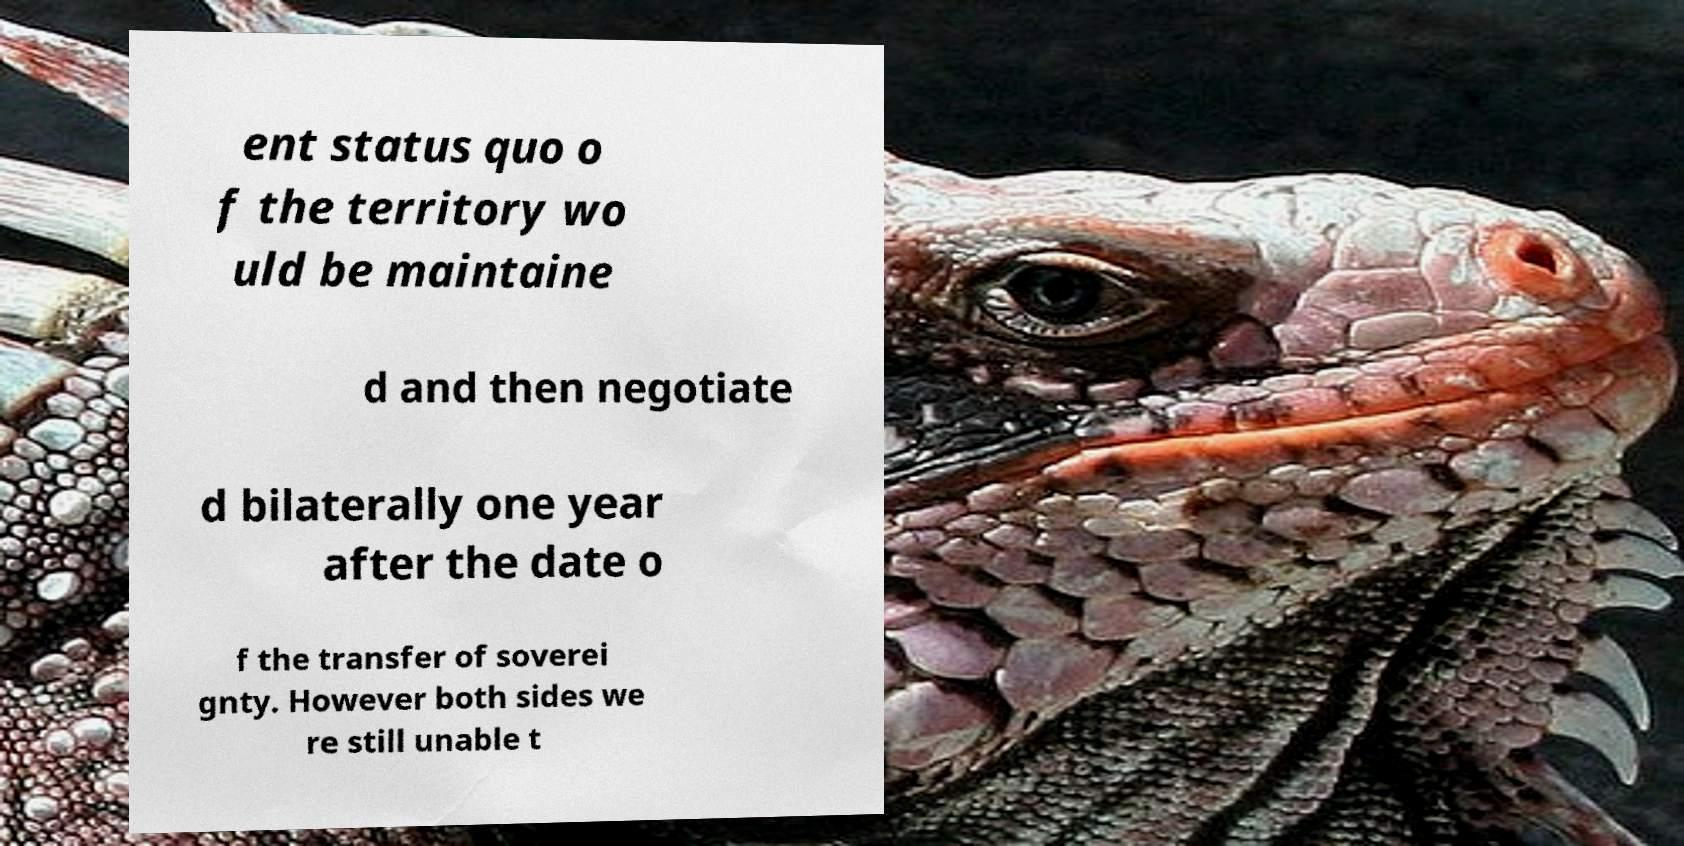Could you assist in decoding the text presented in this image and type it out clearly? ent status quo o f the territory wo uld be maintaine d and then negotiate d bilaterally one year after the date o f the transfer of soverei gnty. However both sides we re still unable t 